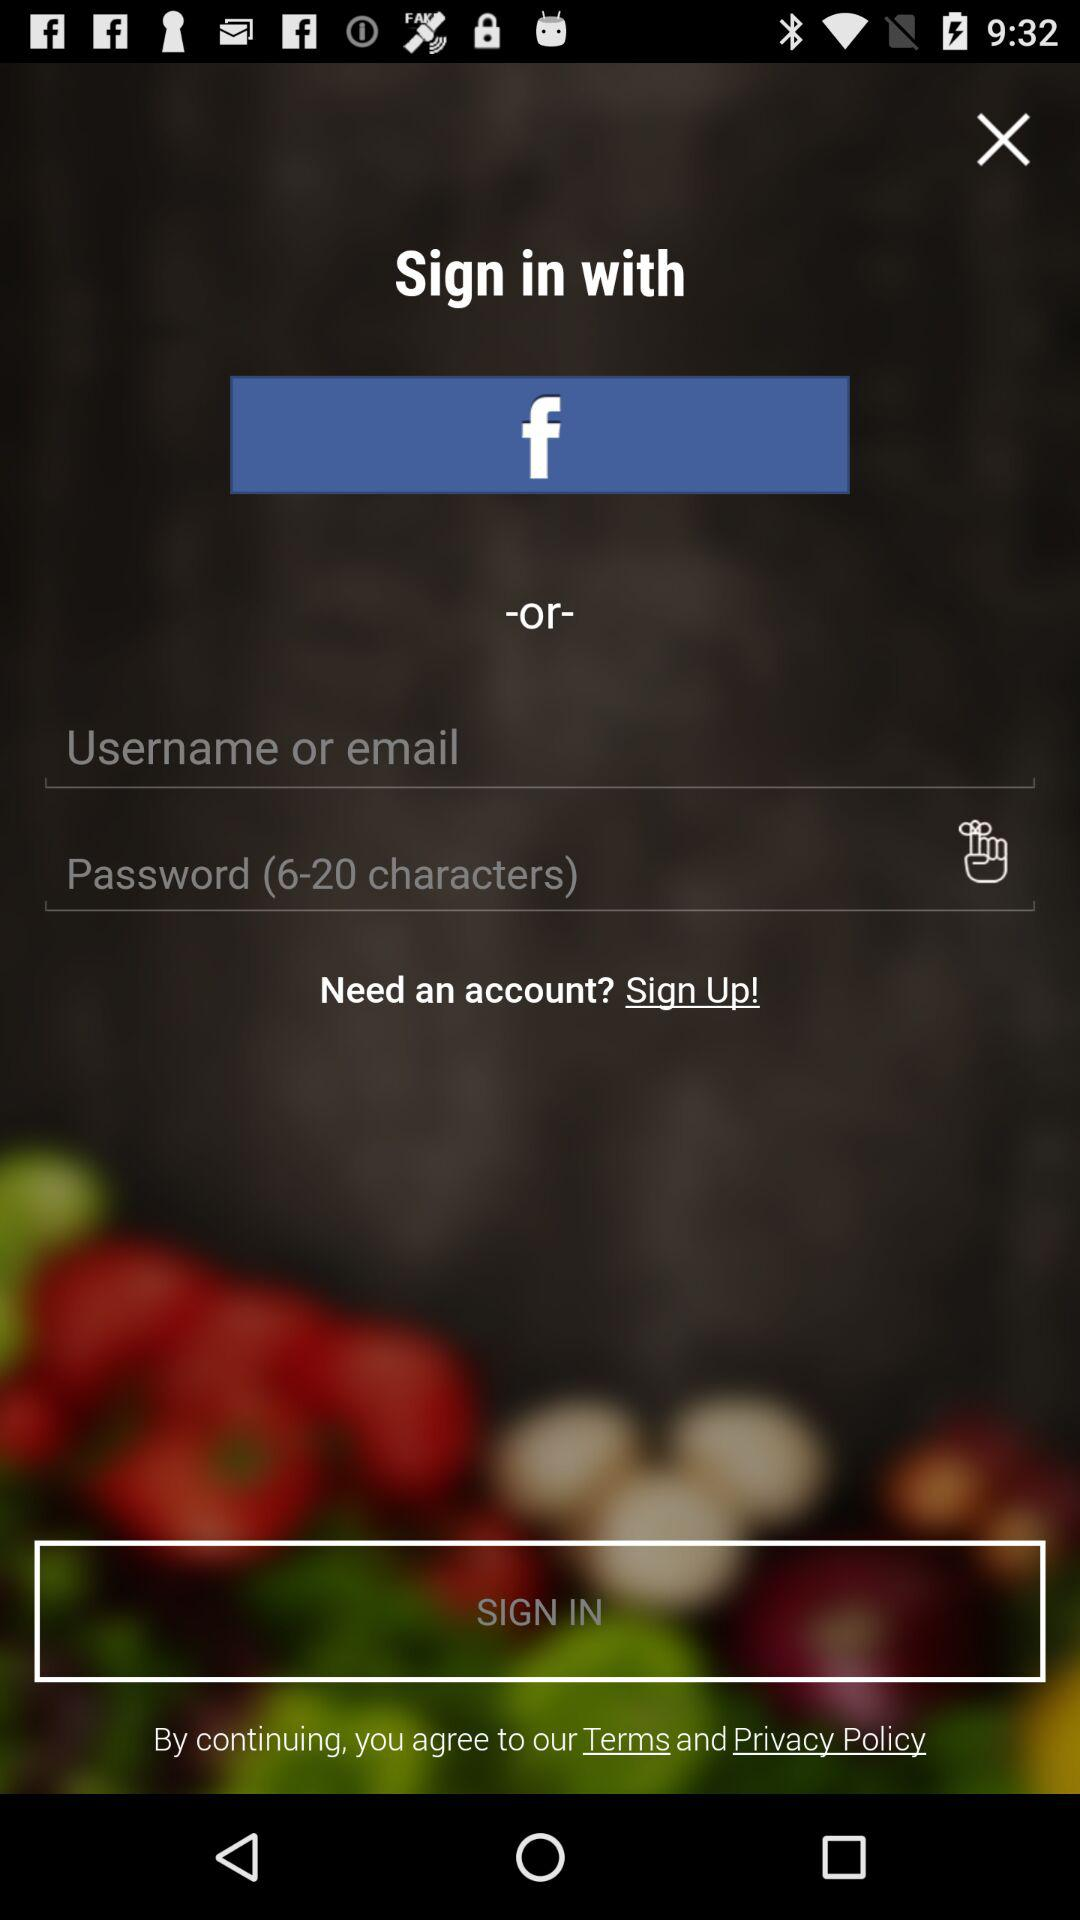What is the other option to sign in? The other option to sign in is "Username or email". 